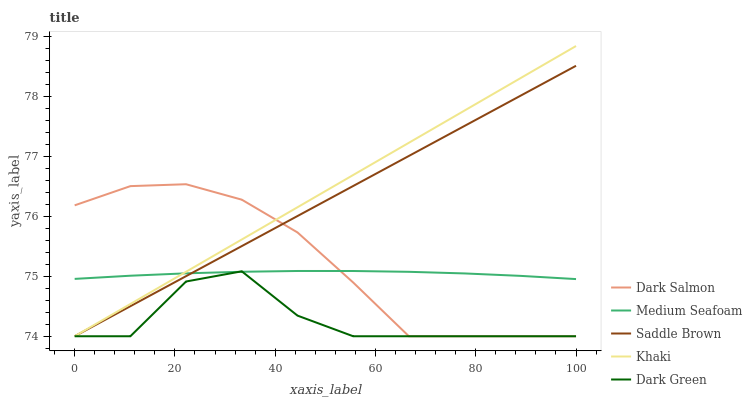Does Dark Green have the minimum area under the curve?
Answer yes or no. Yes. Does Khaki have the maximum area under the curve?
Answer yes or no. Yes. Does Khaki have the minimum area under the curve?
Answer yes or no. No. Does Dark Green have the maximum area under the curve?
Answer yes or no. No. Is Saddle Brown the smoothest?
Answer yes or no. Yes. Is Dark Green the roughest?
Answer yes or no. Yes. Is Khaki the smoothest?
Answer yes or no. No. Is Khaki the roughest?
Answer yes or no. No. Does Saddle Brown have the lowest value?
Answer yes or no. Yes. Does Medium Seafoam have the lowest value?
Answer yes or no. No. Does Khaki have the highest value?
Answer yes or no. Yes. Does Dark Green have the highest value?
Answer yes or no. No. Does Khaki intersect Saddle Brown?
Answer yes or no. Yes. Is Khaki less than Saddle Brown?
Answer yes or no. No. Is Khaki greater than Saddle Brown?
Answer yes or no. No. 